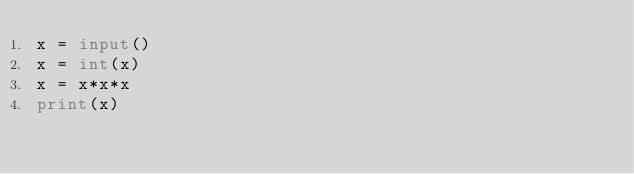Convert code to text. <code><loc_0><loc_0><loc_500><loc_500><_Python_>x = input()
x = int(x)
x = x*x*x
print(x)</code> 